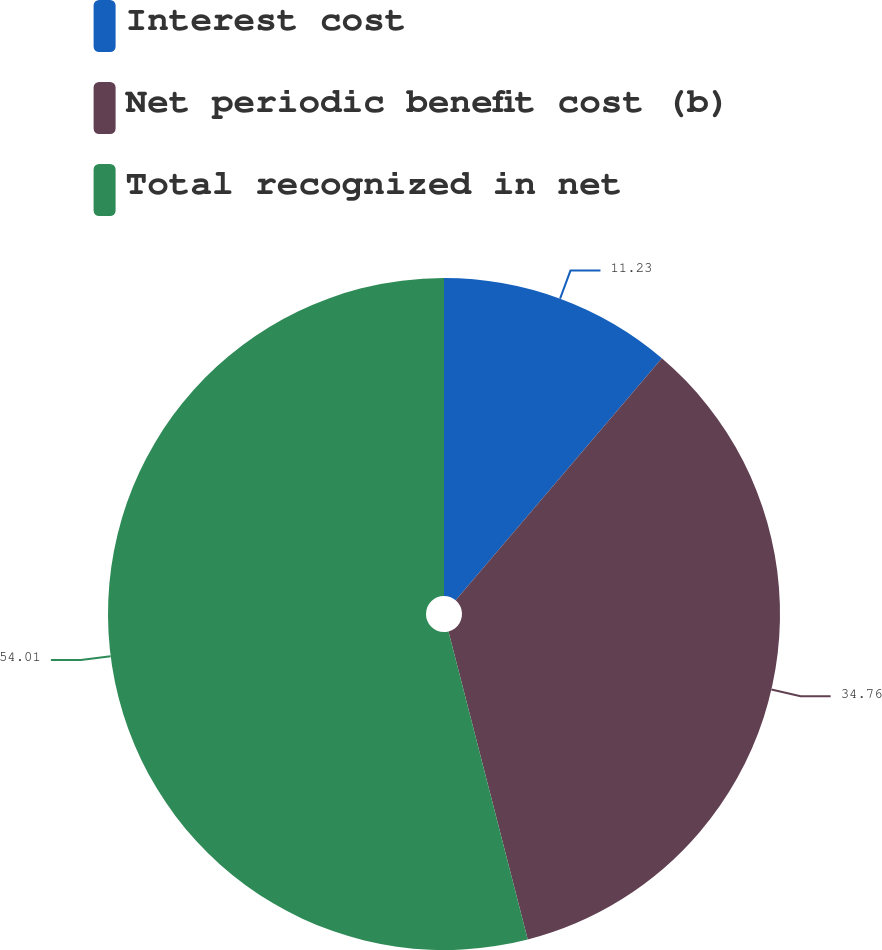Convert chart to OTSL. <chart><loc_0><loc_0><loc_500><loc_500><pie_chart><fcel>Interest cost<fcel>Net periodic benefit cost (b)<fcel>Total recognized in net<nl><fcel>11.23%<fcel>34.76%<fcel>54.01%<nl></chart> 